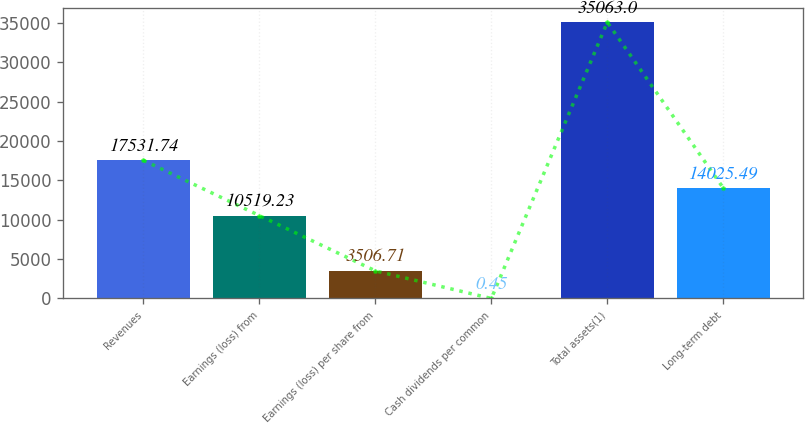<chart> <loc_0><loc_0><loc_500><loc_500><bar_chart><fcel>Revenues<fcel>Earnings (loss) from<fcel>Earnings (loss) per share from<fcel>Cash dividends per common<fcel>Total assets(1)<fcel>Long-term debt<nl><fcel>17531.7<fcel>10519.2<fcel>3506.71<fcel>0.45<fcel>35063<fcel>14025.5<nl></chart> 